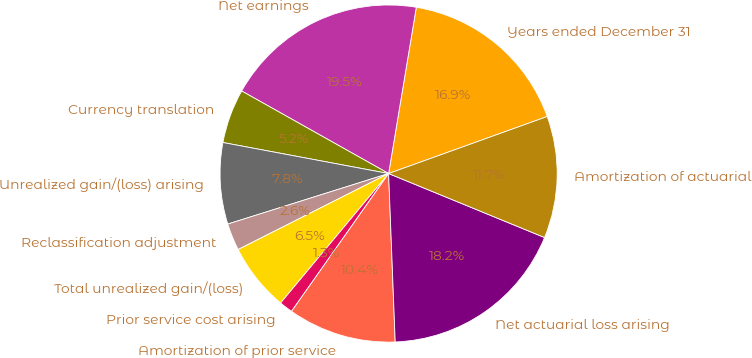Convert chart. <chart><loc_0><loc_0><loc_500><loc_500><pie_chart><fcel>Years ended December 31<fcel>Net earnings<fcel>Currency translation<fcel>Unrealized gain/(loss) arising<fcel>Reclassification adjustment<fcel>Total unrealized gain/(loss)<fcel>Prior service cost arising<fcel>Amortization of prior service<fcel>Net actuarial loss arising<fcel>Amortization of actuarial<nl><fcel>16.88%<fcel>19.48%<fcel>5.2%<fcel>7.79%<fcel>2.6%<fcel>6.49%<fcel>1.3%<fcel>10.39%<fcel>18.18%<fcel>11.69%<nl></chart> 